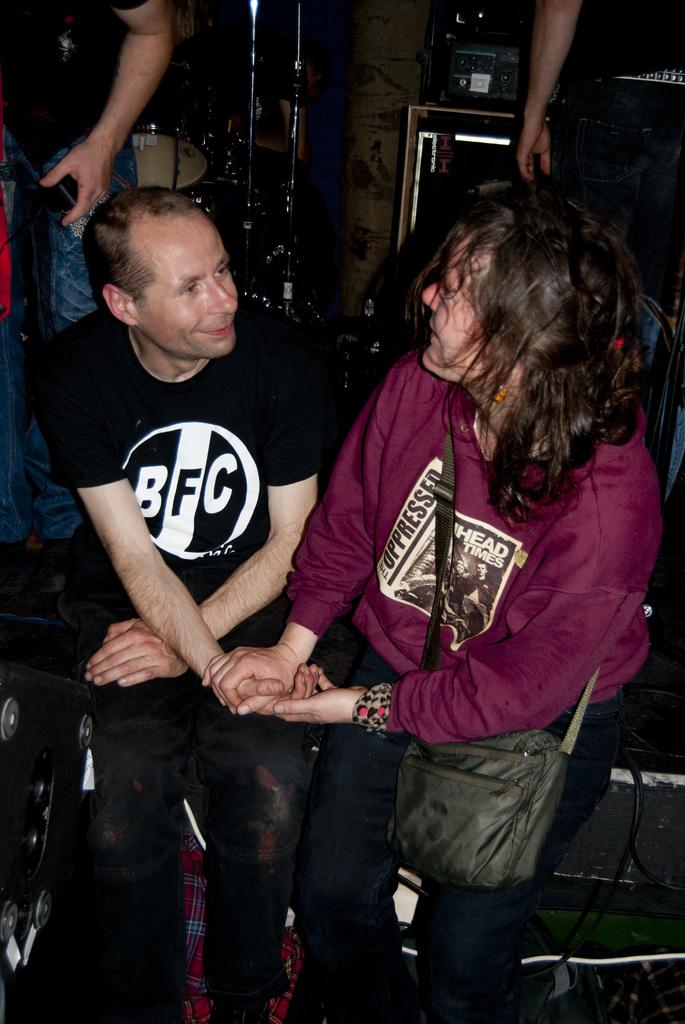<image>
Describe the image concisely. The Oppressed is written in bold letters on a females sweatshirt. 